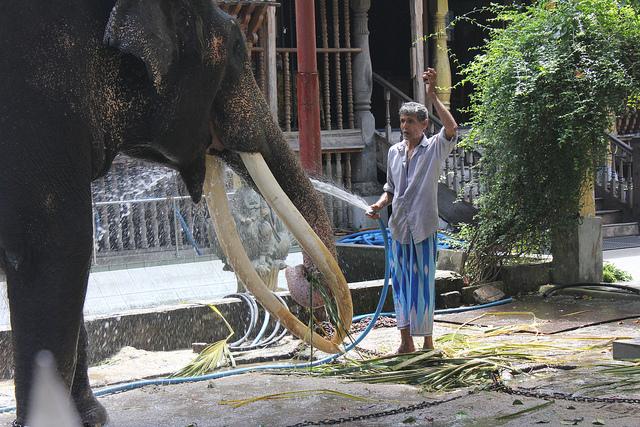Is the elephant aggressive?
Concise answer only. No. Would the fence be effective in stopping the elephant if it tried to get through?
Write a very short answer. No. What is the man doing?
Short answer required. Washing elephant. Which hand is the man holding the hose with?
Keep it brief. Right. 